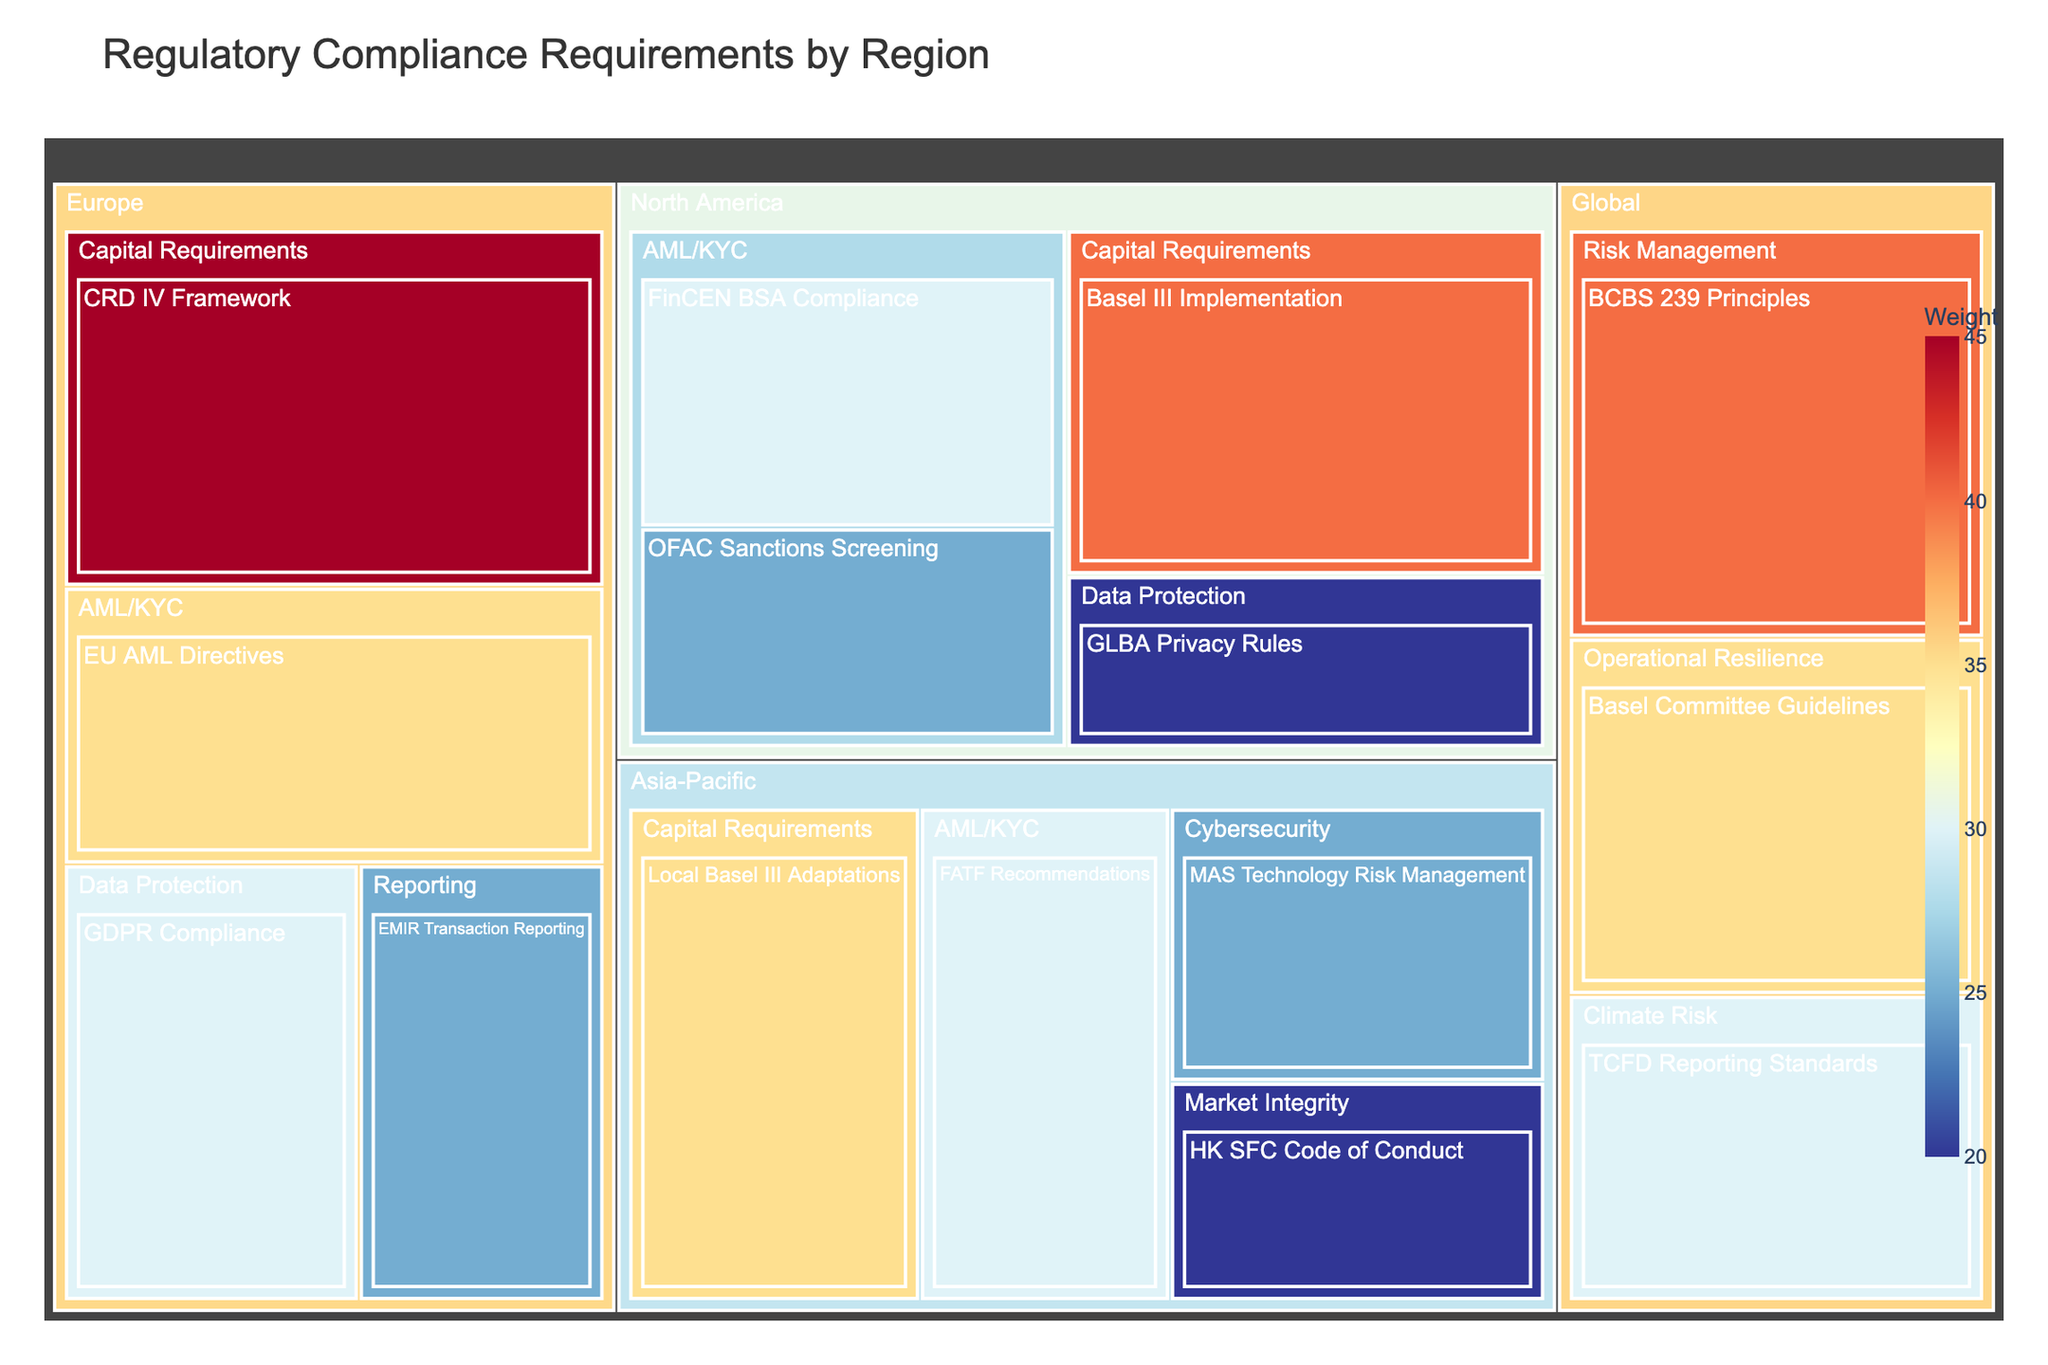What is the title of the treemap? The title is typically located at the top of the figure. In this case, it reads "Regulatory Compliance Requirements by Region."
Answer: Regulatory Compliance Requirements by Region Which regulatory category in North America has the highest weight? By inspecting the North America region in the treemap, the "Capital Requirements" category is the largest by area and therefore has the highest weight at 40.
Answer: Capital Requirements How many requirements are listed under Europe? In the Europe region, four requirements are listed: EU AML Directives, CRD IV Framework, GDPR Compliance, and EMIR Transaction Reporting.
Answer: Four What is the combined weight for Data Protection requirements across all regions? Identify the weights for Data Protection in each region: North America (20) and Europe (30). Sum these values: 20 + 30 = 50.
Answer: 50 Which region has the most diverse categories? By examining the number of different categories within each region: North America (3), Europe (4), Asia-Pacific (4), Global (3). Europe and Asia-Pacific both have 4 categories, making them the most diverse.
Answer: Europe and Asia-Pacific Among the AML/KYC requirements, which one has the lowest weight? Comparing the weights of AML/KYC requirements across regions: FinCEN BSA Compliance (30), OFAC Sanctions Screening (25), EU AML Directives (35), FATF Recommendations (30). The lowest is OFAC Sanctions Screening at 25.
Answer: OFAC Sanctions Screening Compare the weights for Climate Risk and Cybersecurity requirements. Which one is higher? The Climate Risk requirement (Global region - 30) and the Cybersecurity requirement (Asia-Pacific region - 25). Comparing these weights, Climate Risk is higher.
Answer: Climate Risk What is the total weight for all categories in the Asia-Pacific region? Sum the weights of all requirements in the Asia-Pacific region: FATF Recommendations (30), Local Basel III Adaptations (35), HK SFC Code of Conduct (20), MAS Technology Risk Management (25). Total: 30 + 35 + 20 + 25 = 110.
Answer: 110 Which category in the Global region has the second highest weight? The Global region includes BCBS 239 Principles (40), Basel Committee Guidelines (35), TCFD Reporting Standards (30). The second highest weight is 35 for Basel Committee Guidelines.
Answer: Basel Committee Guidelines 